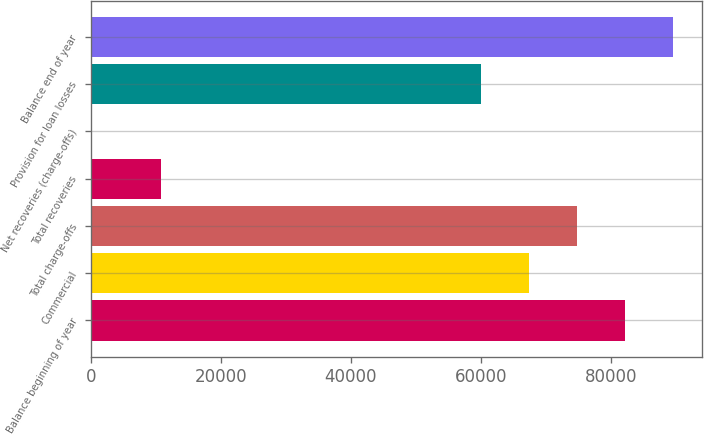<chart> <loc_0><loc_0><loc_500><loc_500><bar_chart><fcel>Balance beginning of year<fcel>Commercial<fcel>Total charge-offs<fcel>Total recoveries<fcel>Net recoveries (charge-offs)<fcel>Provision for loan losses<fcel>Balance end of year<nl><fcel>82120.7<fcel>67361.3<fcel>74741<fcel>10778<fcel>3.3<fcel>59981.7<fcel>89500.4<nl></chart> 